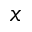<formula> <loc_0><loc_0><loc_500><loc_500>x</formula> 